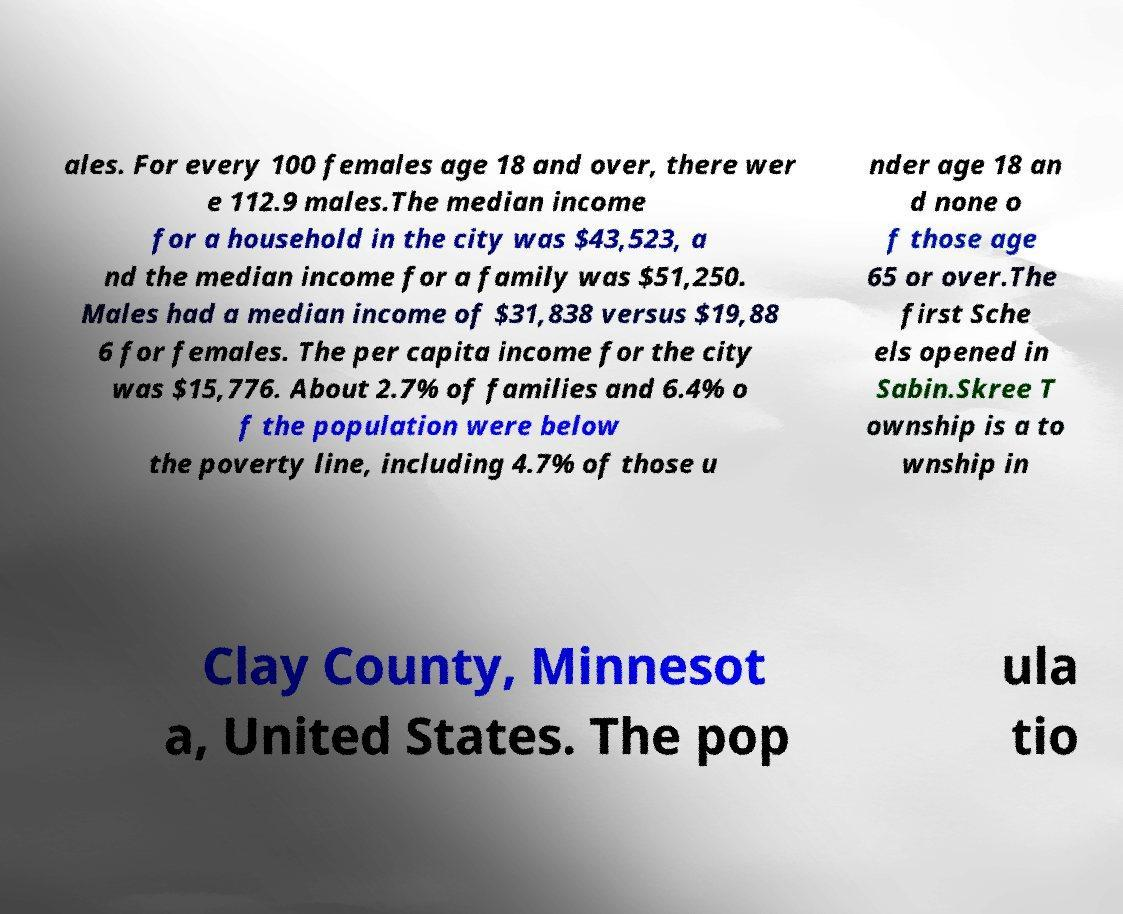I need the written content from this picture converted into text. Can you do that? ales. For every 100 females age 18 and over, there wer e 112.9 males.The median income for a household in the city was $43,523, a nd the median income for a family was $51,250. Males had a median income of $31,838 versus $19,88 6 for females. The per capita income for the city was $15,776. About 2.7% of families and 6.4% o f the population were below the poverty line, including 4.7% of those u nder age 18 an d none o f those age 65 or over.The first Sche els opened in Sabin.Skree T ownship is a to wnship in Clay County, Minnesot a, United States. The pop ula tio 